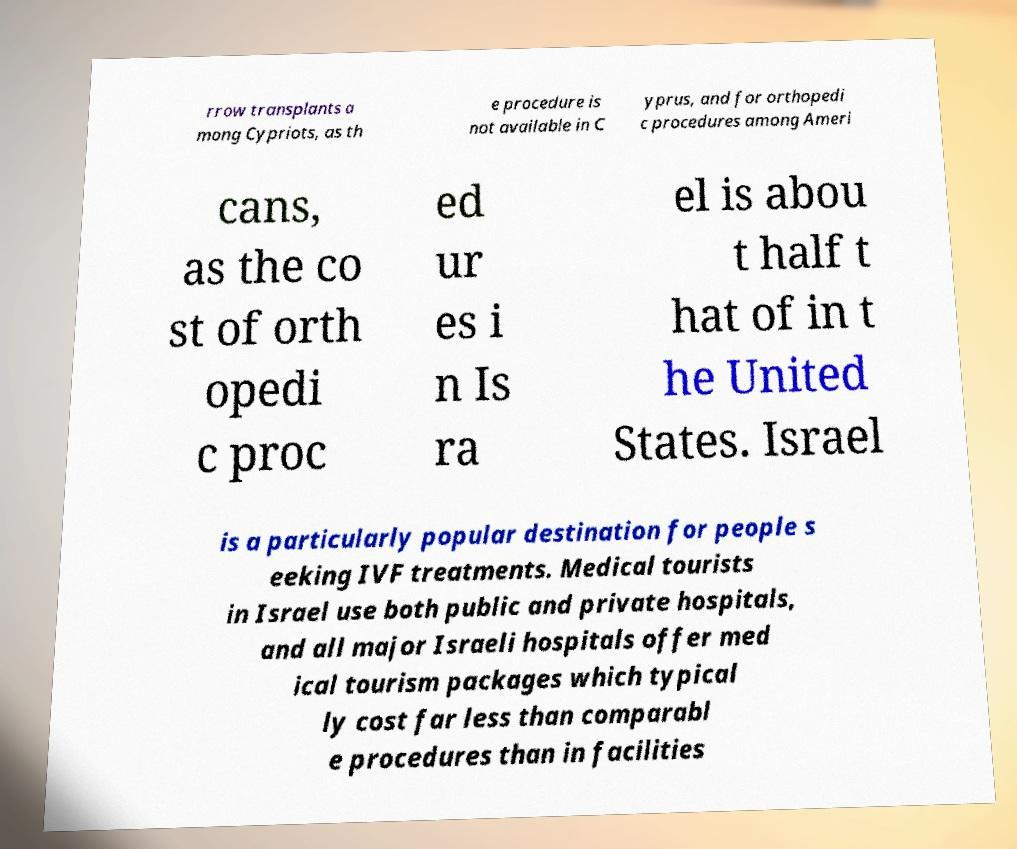I need the written content from this picture converted into text. Can you do that? rrow transplants a mong Cypriots, as th e procedure is not available in C yprus, and for orthopedi c procedures among Ameri cans, as the co st of orth opedi c proc ed ur es i n Is ra el is abou t half t hat of in t he United States. Israel is a particularly popular destination for people s eeking IVF treatments. Medical tourists in Israel use both public and private hospitals, and all major Israeli hospitals offer med ical tourism packages which typical ly cost far less than comparabl e procedures than in facilities 